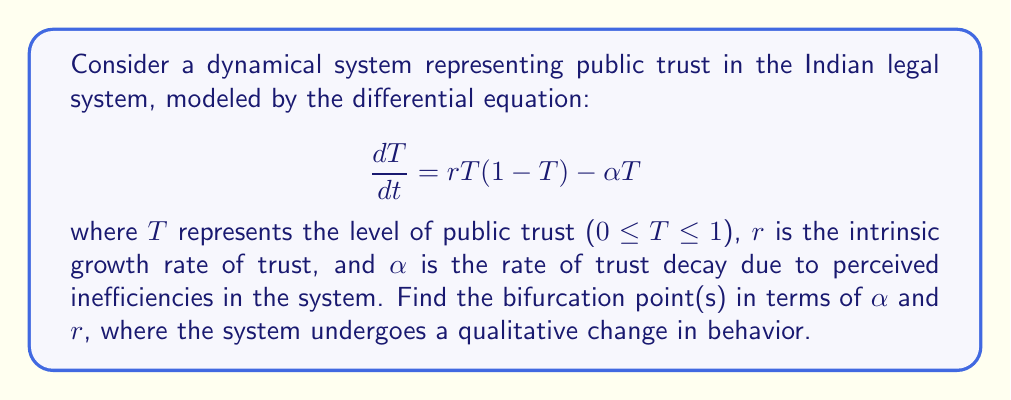Help me with this question. To find the bifurcation points, we need to analyze the equilibria of the system and determine when they change stability. Let's proceed step-by-step:

1) First, find the equilibria by setting $\frac{dT}{dt} = 0$:

   $$rT(1-T) - \alpha T = 0$$

2) Factor out T:

   $$T(r(1-T) - \alpha) = 0$$

3) Solve for T:

   $T = 0$ or $r(1-T) - \alpha = 0$
   
   For the second equation: $T = 1 - \frac{\alpha}{r}$

4) The non-zero equilibrium exists only when $0 < 1 - \frac{\alpha}{r} < 1$, which implies $0 < \alpha < r$.

5) Now, let's analyze the stability of these equilibria. The derivative of the right-hand side with respect to T is:

   $$\frac{d}{dT}(rT(1-T) - \alpha T) = r(1-2T) - \alpha$$

6) At $T = 0$, the derivative is $r - \alpha$. The equilibrium changes stability when $r - \alpha = 0$, or $\alpha = r$.

7) At $T = 1 - \frac{\alpha}{r}$, the derivative is $-r + \alpha$. This equilibrium exists and changes stability at the same point: $\alpha = r$.

8) Therefore, the bifurcation point occurs when $\alpha = r$. At this point, the non-zero equilibrium collides with the zero equilibrium and exchanges stability.

This bifurcation is known as a transcritical bifurcation. When $\alpha < r$, the non-zero equilibrium is stable and the zero equilibrium is unstable. When $\alpha > r$, the zero equilibrium becomes stable and the non-zero equilibrium disappears.
Answer: $\alpha = r$ 